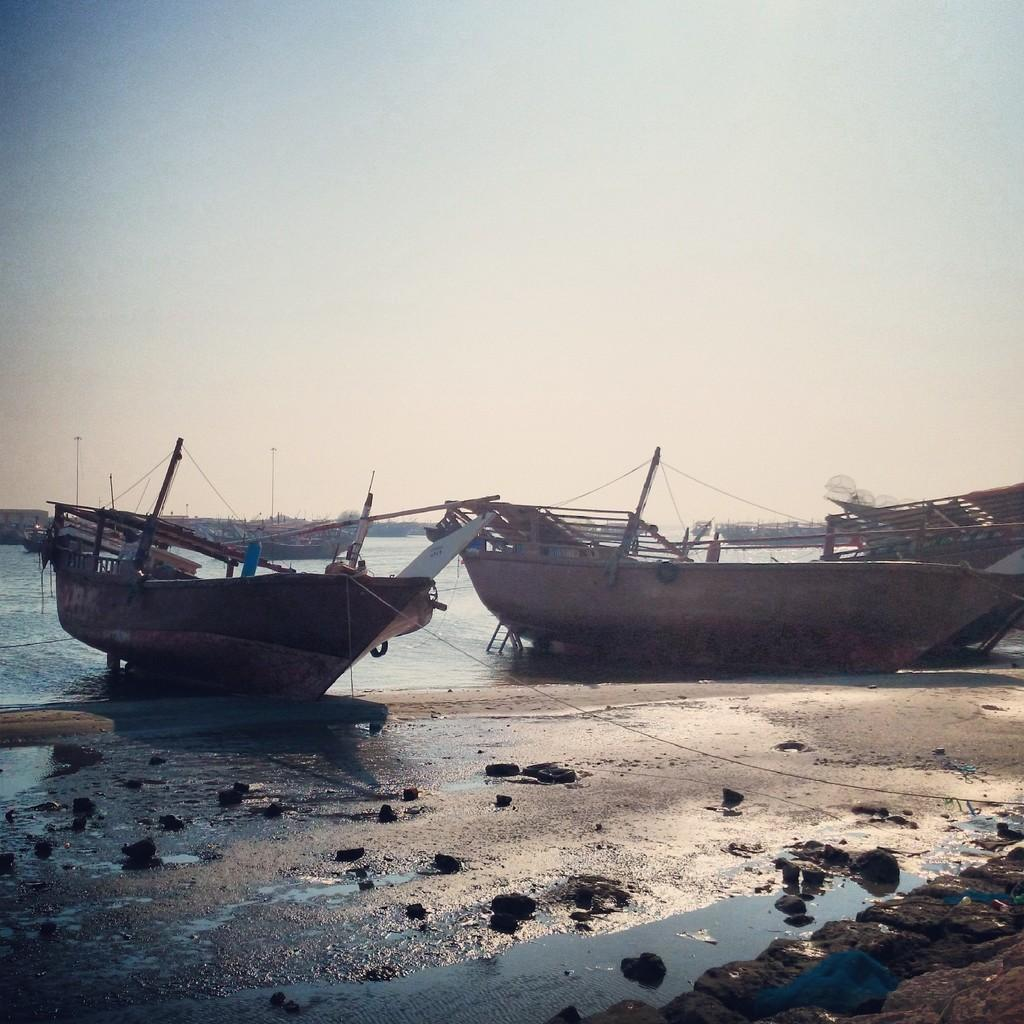What is the main subject of the image? The main subject of the image is boats. Where are the boats located? The boats are on the water. What else can be seen in the image besides the boats? The sky is visible in the image. How would you describe the sky in the image? The sky appears to be cloudy. Can you see a flock of birds flying over the boats in the image? There is no mention of birds or a flock in the image, so we cannot confirm their presence. 